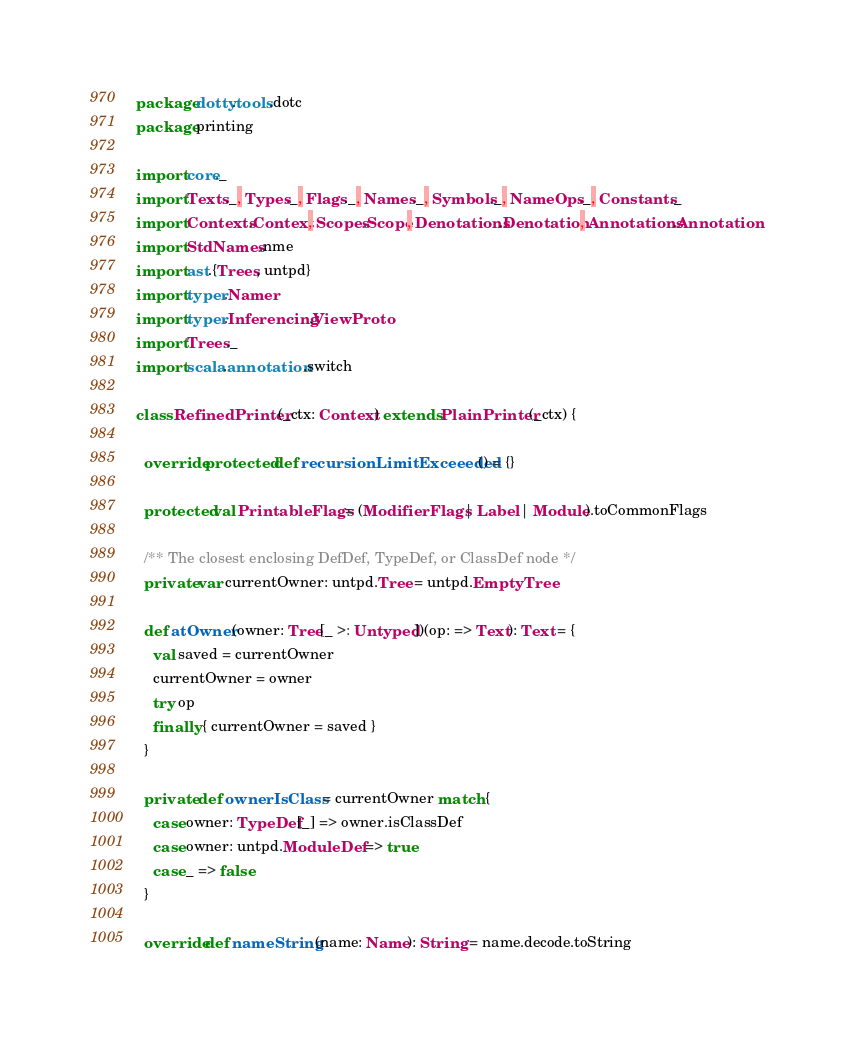Convert code to text. <code><loc_0><loc_0><loc_500><loc_500><_Scala_>package dotty.tools.dotc
package printing

import core._
import Texts._, Types._, Flags._, Names._, Symbols._, NameOps._, Constants._
import Contexts.Context, Scopes.Scope, Denotations.Denotation, Annotations.Annotation
import StdNames.nme
import ast.{Trees, untpd}
import typer.Namer
import typer.Inferencing.ViewProto
import Trees._
import scala.annotation.switch

class RefinedPrinter(_ctx: Context) extends PlainPrinter(_ctx) {

  override protected def recursionLimitExceeeded() = {}

  protected val PrintableFlags = (ModifierFlags | Label | Module).toCommonFlags

  /** The closest enclosing DefDef, TypeDef, or ClassDef node */
  private var currentOwner: untpd.Tree = untpd.EmptyTree

  def atOwner(owner: Tree[_ >: Untyped])(op: => Text): Text = {
    val saved = currentOwner
    currentOwner = owner
    try op
    finally { currentOwner = saved }
  }

  private def ownerIsClass = currentOwner match {
    case owner: TypeDef[_] => owner.isClassDef
    case owner: untpd.ModuleDef => true
    case _ => false
  }

  override def nameString(name: Name): String = name.decode.toString
</code> 